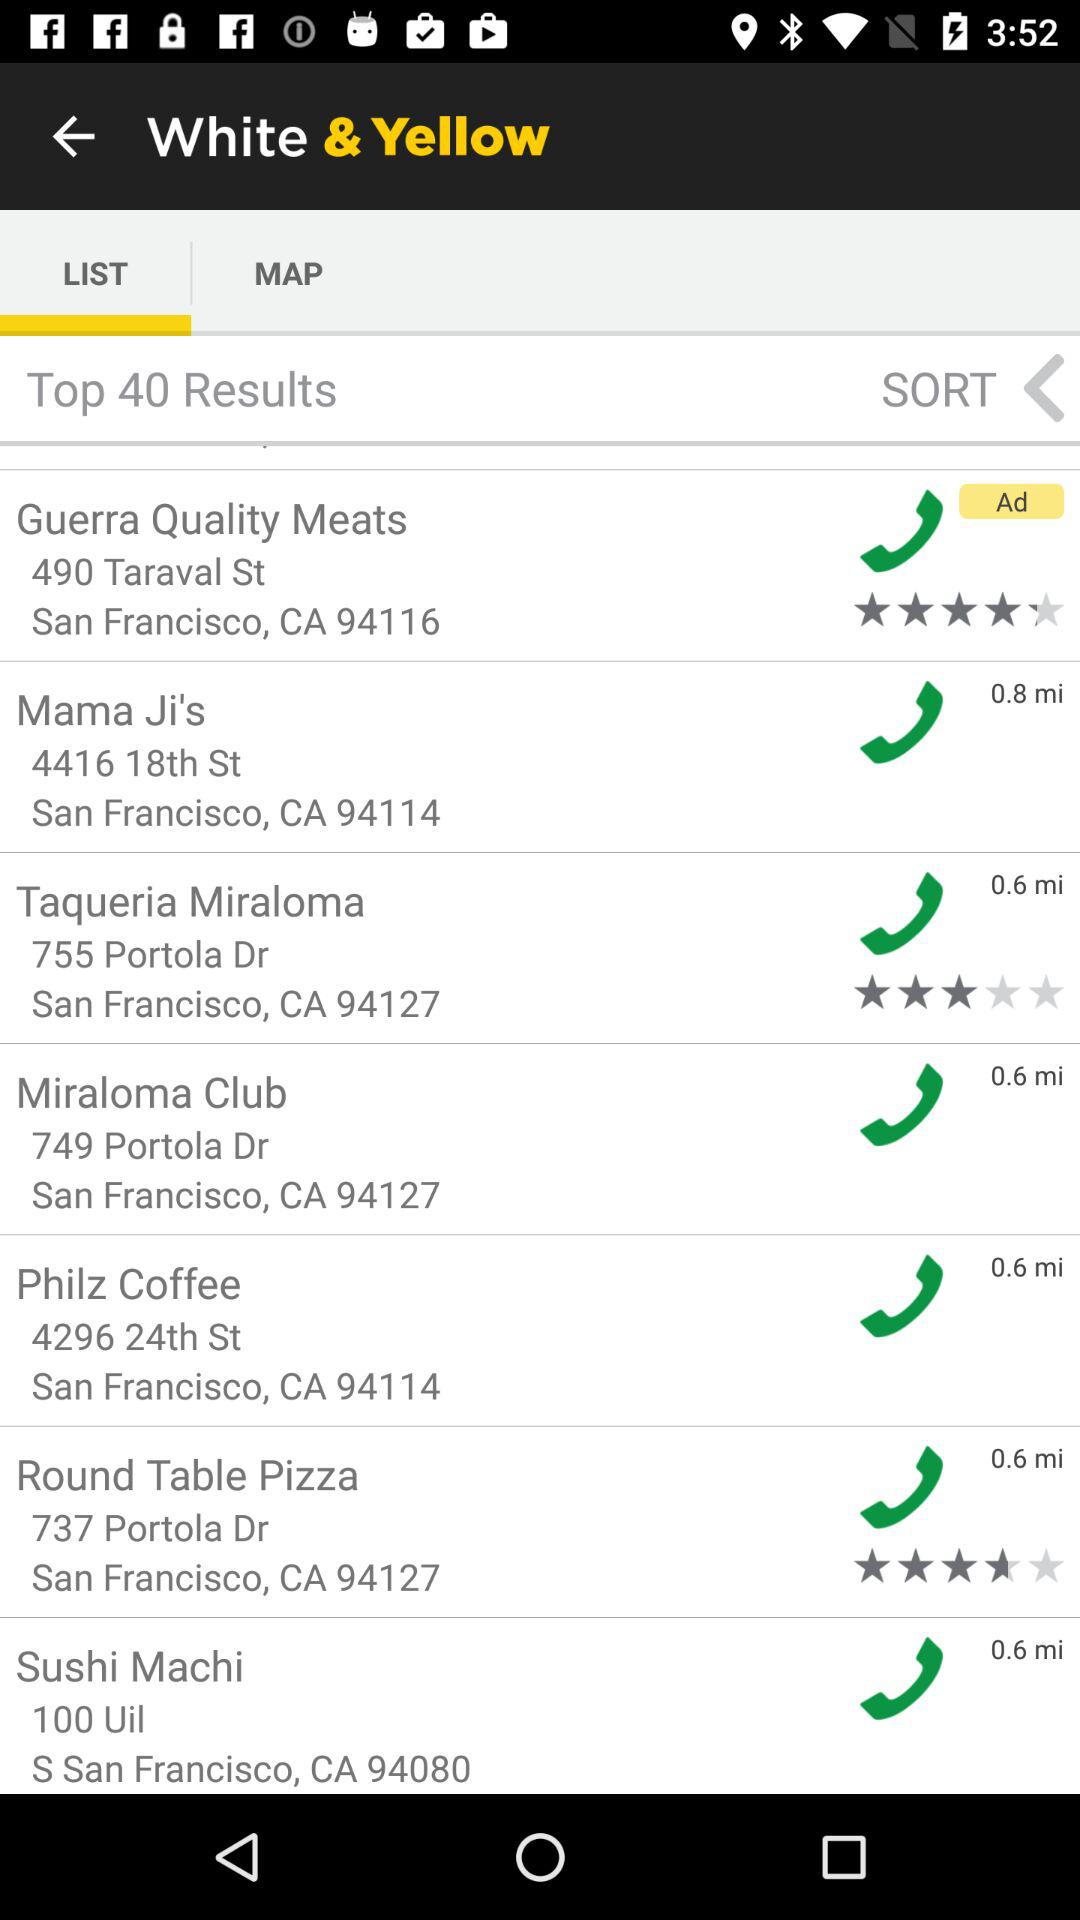What state is mentioned? The mentioned state is California. 